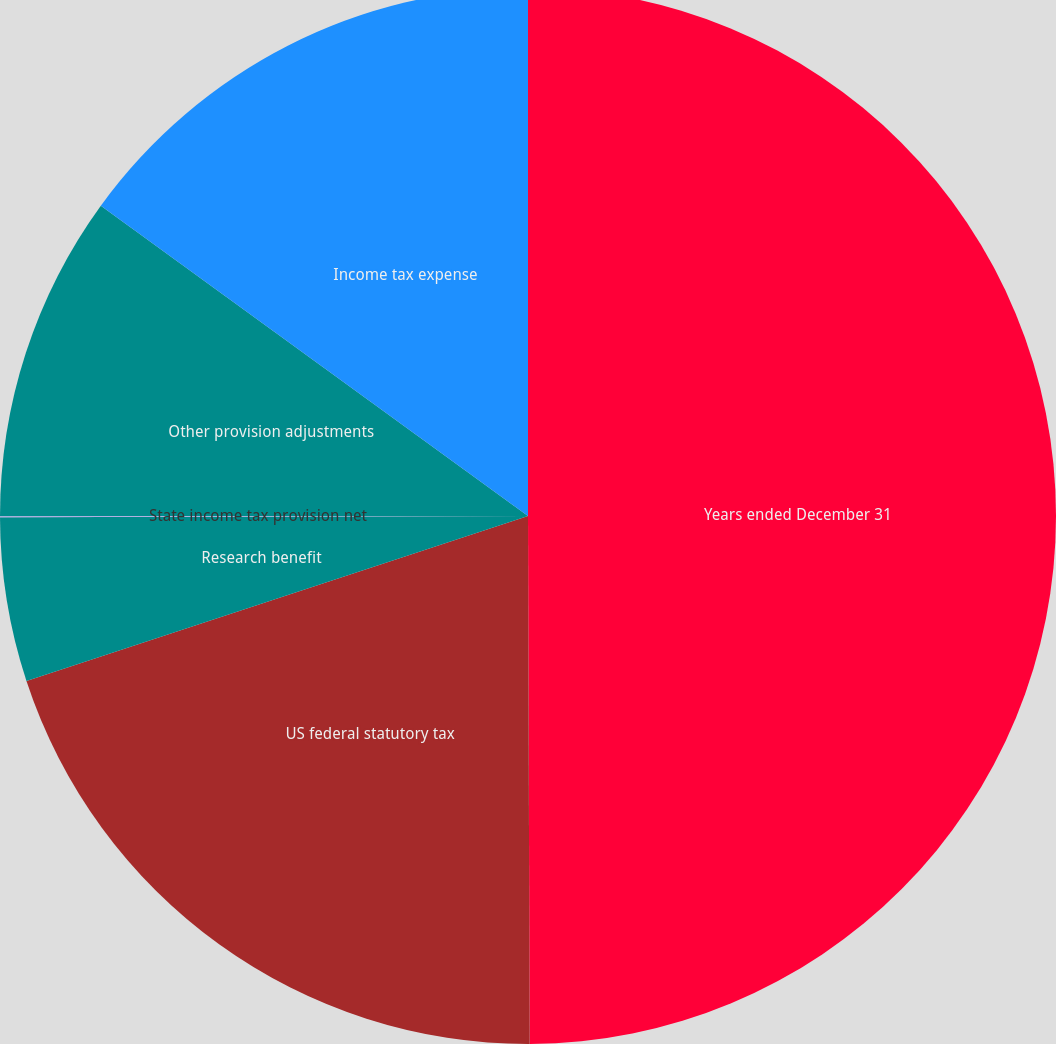Convert chart to OTSL. <chart><loc_0><loc_0><loc_500><loc_500><pie_chart><fcel>Years ended December 31<fcel>US federal statutory tax<fcel>Research benefit<fcel>State income tax provision net<fcel>Other provision adjustments<fcel>Income tax expense<nl><fcel>49.95%<fcel>19.99%<fcel>5.02%<fcel>0.03%<fcel>10.01%<fcel>15.0%<nl></chart> 